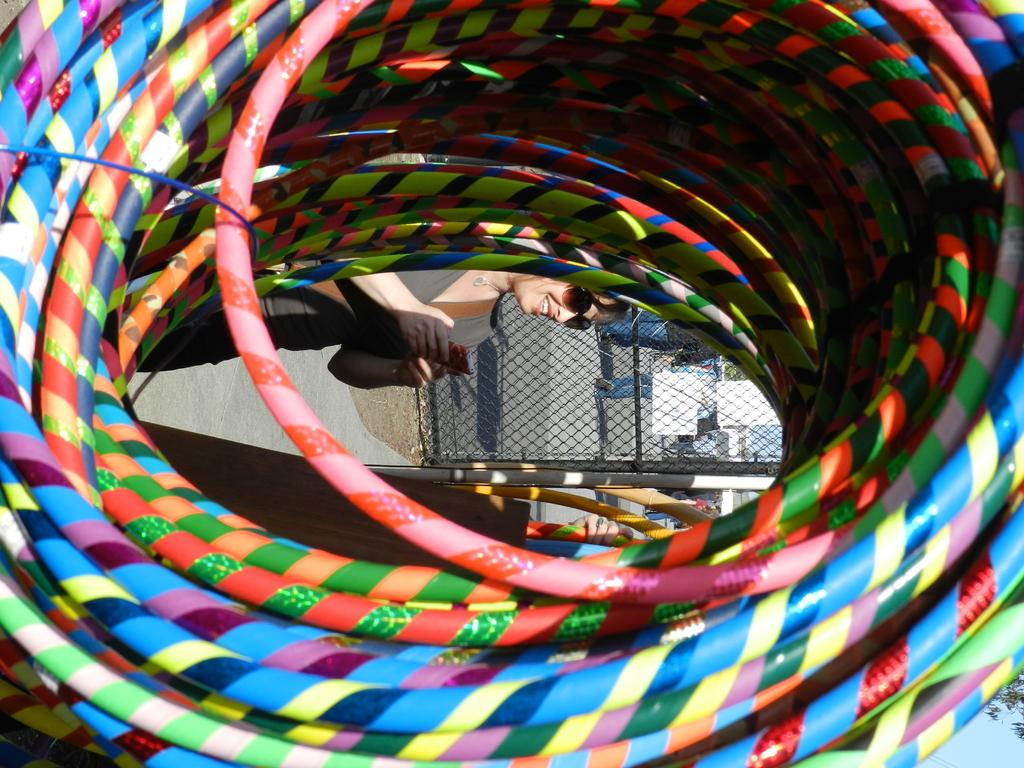What is the main subject of the image? The main subject of the image is a bundle of colorful pipes. What is the woman in the image doing? The woman is standing through the gap in the pipes. What can be seen beneath the pipes in the image? The ground is visible in the image. What type of fencing is present in the image? There is metal fencing in the image. What structures can be seen in the background of the image? There are buildings visible in the image. What offer is the woman making through the gap in the pipes? There is no indication in the image that the woman is making any offer; she is simply standing through the gap in the pipes. 